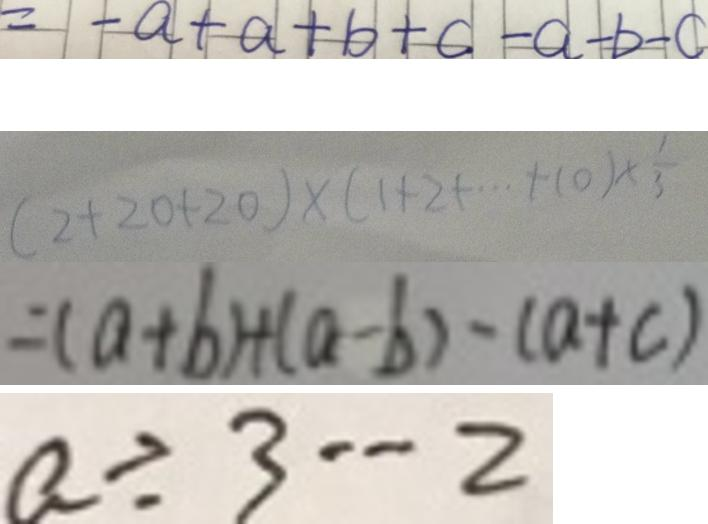<formula> <loc_0><loc_0><loc_500><loc_500>= - a + a + b + c - a - b - c 
 ( 2 + 2 0 + 2 0 ) \times ( 1 + 2 + \cdots + 1 0 ) \times \frac { 1 } { 3 } 
 = ( a + b ) + ( a - b ) - ( a + c ) 
 a \div 3 \cdots 2</formula> 